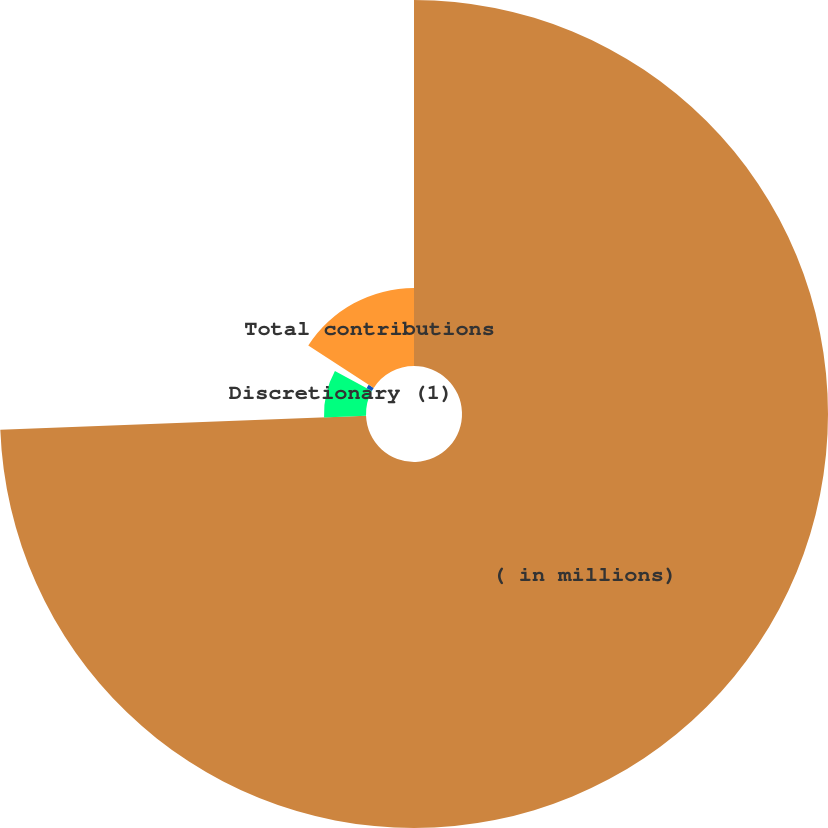<chart> <loc_0><loc_0><loc_500><loc_500><pie_chart><fcel>( in millions)<fcel>Discretionary (1)<fcel>Other benefit plans<fcel>Total contributions<nl><fcel>74.39%<fcel>8.54%<fcel>1.22%<fcel>15.85%<nl></chart> 